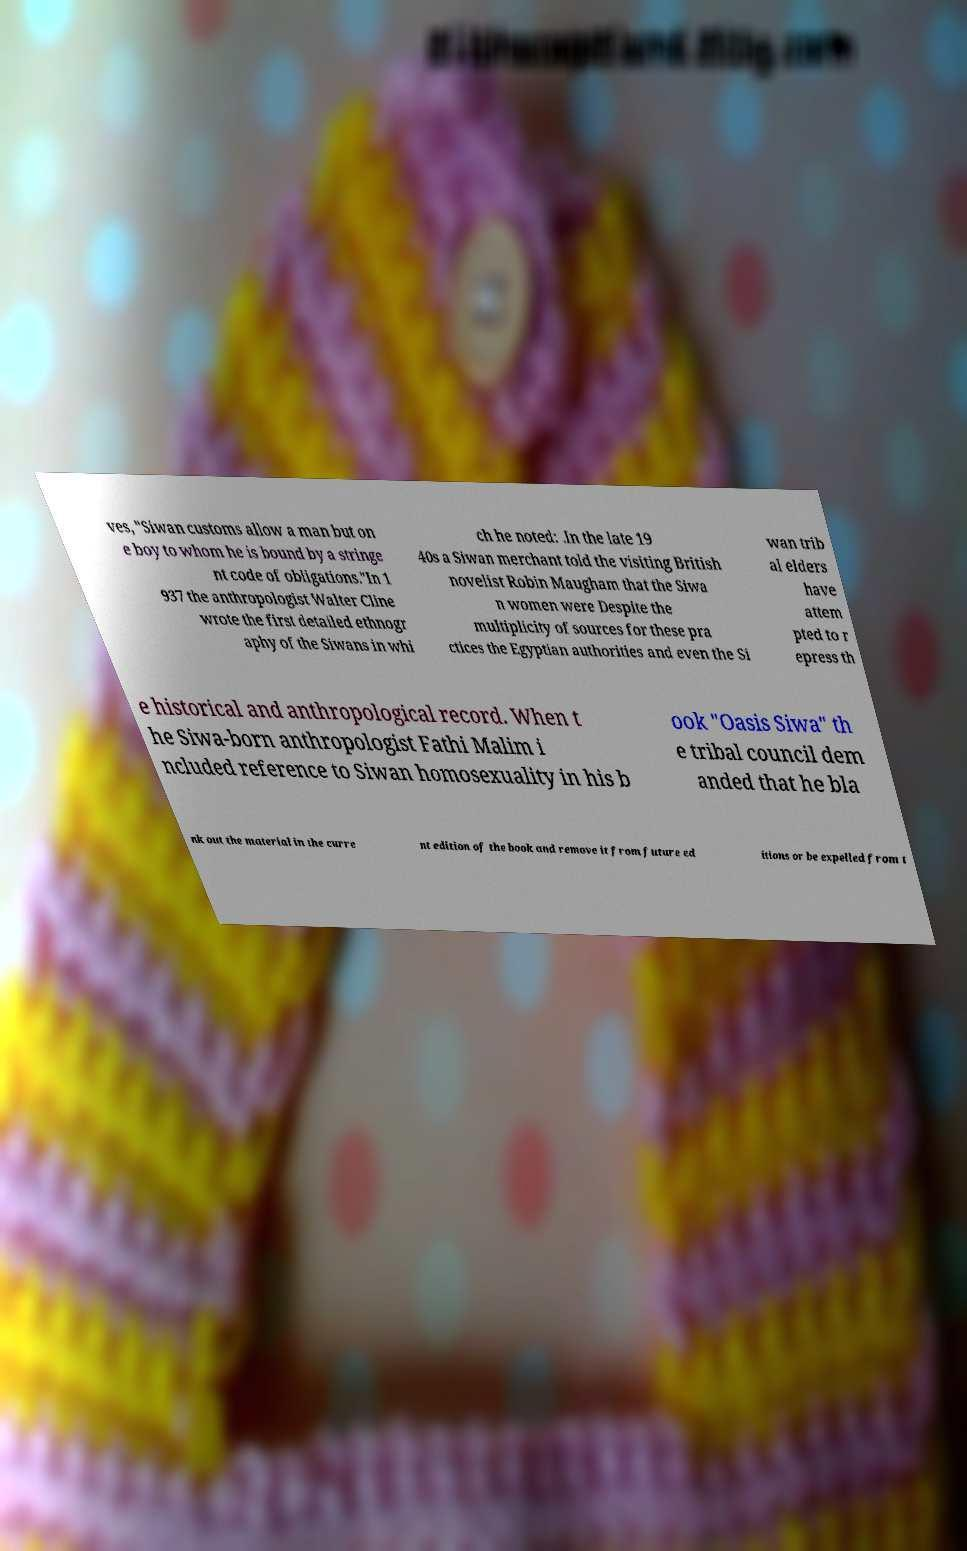Could you assist in decoding the text presented in this image and type it out clearly? ves, "Siwan customs allow a man but on e boy to whom he is bound by a stringe nt code of obligations."In 1 937 the anthropologist Walter Cline wrote the first detailed ethnogr aphy of the Siwans in whi ch he noted: .In the late 19 40s a Siwan merchant told the visiting British novelist Robin Maugham that the Siwa n women were Despite the multiplicity of sources for these pra ctices the Egyptian authorities and even the Si wan trib al elders have attem pted to r epress th e historical and anthropological record. When t he Siwa-born anthropologist Fathi Malim i ncluded reference to Siwan homosexuality in his b ook "Oasis Siwa" th e tribal council dem anded that he bla nk out the material in the curre nt edition of the book and remove it from future ed itions or be expelled from t 